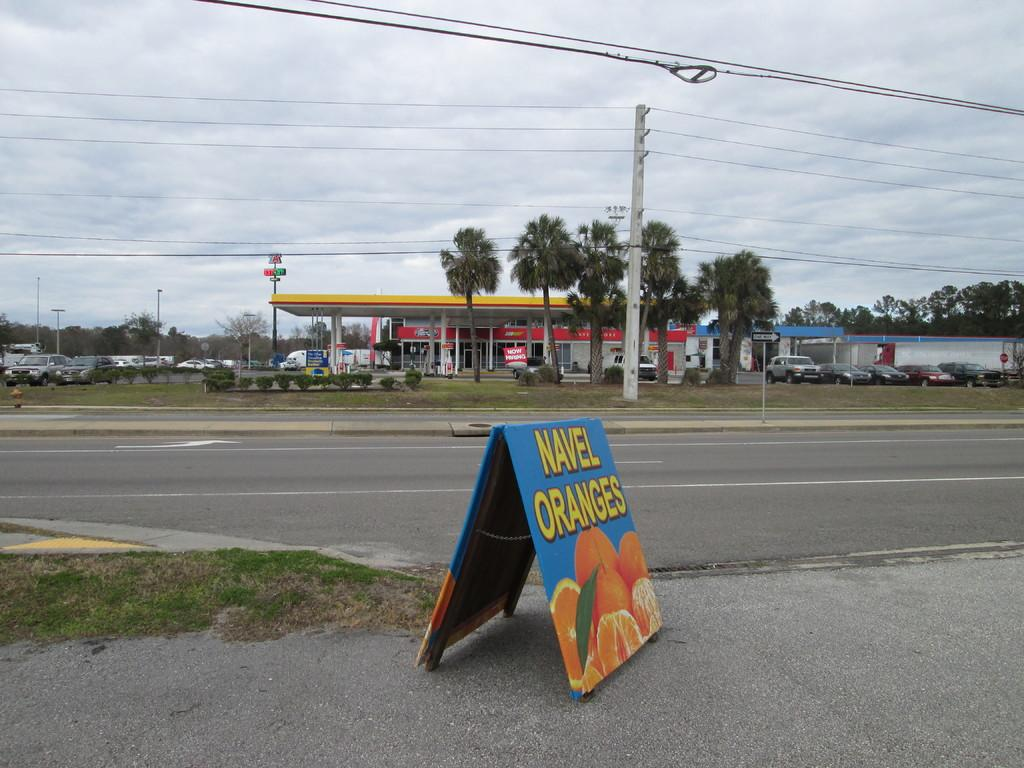Provide a one-sentence caption for the provided image. A gas station with a yellow roof, a road and then a sign that is blue with oranges on it and in yellow letters it says NAVEL ORANGES. 